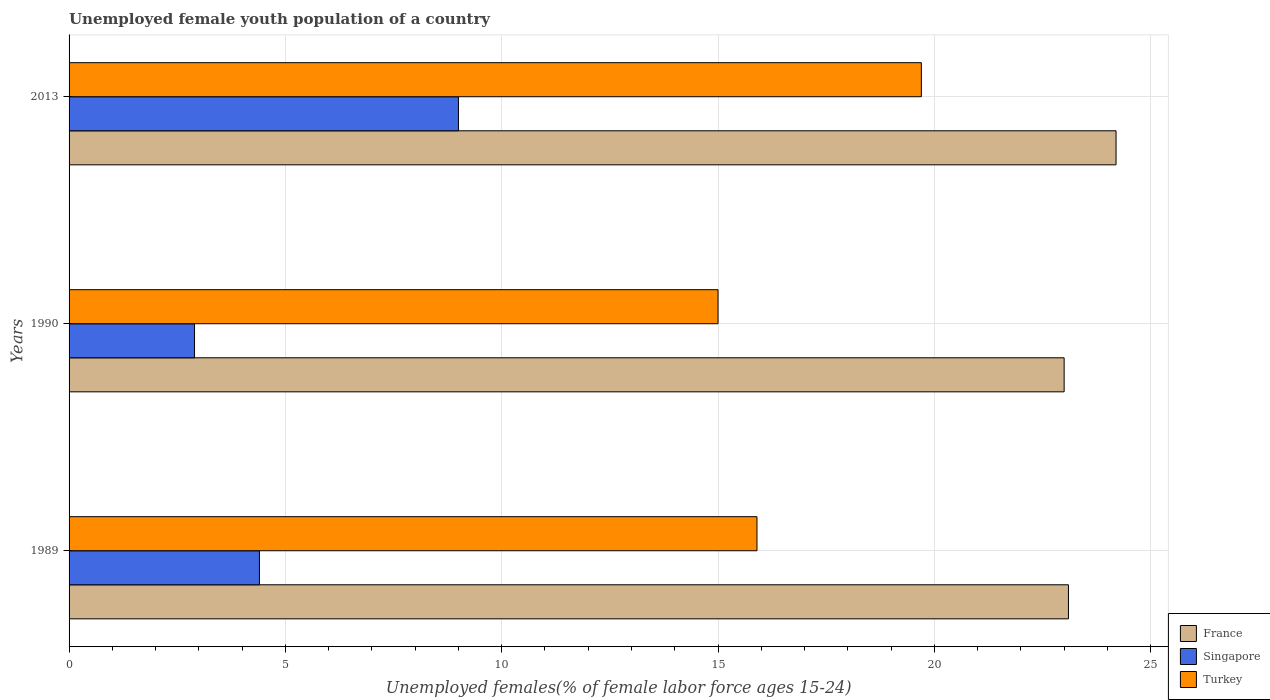How many groups of bars are there?
Offer a very short reply. 3. Are the number of bars per tick equal to the number of legend labels?
Ensure brevity in your answer.  Yes. How many bars are there on the 1st tick from the bottom?
Make the answer very short. 3. What is the label of the 3rd group of bars from the top?
Offer a terse response. 1989. Across all years, what is the maximum percentage of unemployed female youth population in Turkey?
Offer a terse response. 19.7. Across all years, what is the minimum percentage of unemployed female youth population in France?
Give a very brief answer. 23. What is the total percentage of unemployed female youth population in Turkey in the graph?
Make the answer very short. 50.6. What is the difference between the percentage of unemployed female youth population in Turkey in 1989 and that in 2013?
Keep it short and to the point. -3.8. What is the difference between the percentage of unemployed female youth population in Turkey in 1989 and the percentage of unemployed female youth population in Singapore in 2013?
Give a very brief answer. 6.9. What is the average percentage of unemployed female youth population in France per year?
Make the answer very short. 23.43. In the year 1989, what is the difference between the percentage of unemployed female youth population in Turkey and percentage of unemployed female youth population in France?
Offer a very short reply. -7.2. In how many years, is the percentage of unemployed female youth population in Turkey greater than 4 %?
Provide a succinct answer. 3. What is the ratio of the percentage of unemployed female youth population in Singapore in 1989 to that in 2013?
Provide a succinct answer. 0.49. Is the percentage of unemployed female youth population in France in 1989 less than that in 2013?
Your answer should be very brief. Yes. What is the difference between the highest and the second highest percentage of unemployed female youth population in Turkey?
Offer a very short reply. 3.8. What is the difference between the highest and the lowest percentage of unemployed female youth population in France?
Your response must be concise. 1.2. What does the 2nd bar from the top in 1990 represents?
Offer a very short reply. Singapore. What does the 2nd bar from the bottom in 2013 represents?
Provide a short and direct response. Singapore. Is it the case that in every year, the sum of the percentage of unemployed female youth population in Turkey and percentage of unemployed female youth population in Singapore is greater than the percentage of unemployed female youth population in France?
Provide a short and direct response. No. How many bars are there?
Your answer should be very brief. 9. Are all the bars in the graph horizontal?
Your response must be concise. Yes. How many years are there in the graph?
Provide a short and direct response. 3. Are the values on the major ticks of X-axis written in scientific E-notation?
Provide a succinct answer. No. Does the graph contain any zero values?
Give a very brief answer. No. Where does the legend appear in the graph?
Provide a succinct answer. Bottom right. What is the title of the graph?
Provide a short and direct response. Unemployed female youth population of a country. What is the label or title of the X-axis?
Your answer should be very brief. Unemployed females(% of female labor force ages 15-24). What is the Unemployed females(% of female labor force ages 15-24) in France in 1989?
Keep it short and to the point. 23.1. What is the Unemployed females(% of female labor force ages 15-24) of Singapore in 1989?
Give a very brief answer. 4.4. What is the Unemployed females(% of female labor force ages 15-24) in Turkey in 1989?
Offer a terse response. 15.9. What is the Unemployed females(% of female labor force ages 15-24) of France in 1990?
Ensure brevity in your answer.  23. What is the Unemployed females(% of female labor force ages 15-24) of Singapore in 1990?
Provide a short and direct response. 2.9. What is the Unemployed females(% of female labor force ages 15-24) of Turkey in 1990?
Provide a succinct answer. 15. What is the Unemployed females(% of female labor force ages 15-24) of France in 2013?
Your response must be concise. 24.2. What is the Unemployed females(% of female labor force ages 15-24) of Turkey in 2013?
Your answer should be compact. 19.7. Across all years, what is the maximum Unemployed females(% of female labor force ages 15-24) in France?
Keep it short and to the point. 24.2. Across all years, what is the maximum Unemployed females(% of female labor force ages 15-24) in Turkey?
Give a very brief answer. 19.7. Across all years, what is the minimum Unemployed females(% of female labor force ages 15-24) of Singapore?
Give a very brief answer. 2.9. What is the total Unemployed females(% of female labor force ages 15-24) of France in the graph?
Offer a very short reply. 70.3. What is the total Unemployed females(% of female labor force ages 15-24) of Singapore in the graph?
Offer a very short reply. 16.3. What is the total Unemployed females(% of female labor force ages 15-24) in Turkey in the graph?
Give a very brief answer. 50.6. What is the difference between the Unemployed females(% of female labor force ages 15-24) in Singapore in 1989 and that in 1990?
Offer a very short reply. 1.5. What is the difference between the Unemployed females(% of female labor force ages 15-24) in Turkey in 1989 and that in 1990?
Provide a succinct answer. 0.9. What is the difference between the Unemployed females(% of female labor force ages 15-24) of Singapore in 1989 and that in 2013?
Give a very brief answer. -4.6. What is the difference between the Unemployed females(% of female labor force ages 15-24) of France in 1990 and that in 2013?
Provide a short and direct response. -1.2. What is the difference between the Unemployed females(% of female labor force ages 15-24) of France in 1989 and the Unemployed females(% of female labor force ages 15-24) of Singapore in 1990?
Offer a terse response. 20.2. What is the difference between the Unemployed females(% of female labor force ages 15-24) of France in 1989 and the Unemployed females(% of female labor force ages 15-24) of Turkey in 1990?
Your response must be concise. 8.1. What is the difference between the Unemployed females(% of female labor force ages 15-24) in France in 1989 and the Unemployed females(% of female labor force ages 15-24) in Turkey in 2013?
Make the answer very short. 3.4. What is the difference between the Unemployed females(% of female labor force ages 15-24) of Singapore in 1989 and the Unemployed females(% of female labor force ages 15-24) of Turkey in 2013?
Your answer should be very brief. -15.3. What is the difference between the Unemployed females(% of female labor force ages 15-24) in France in 1990 and the Unemployed females(% of female labor force ages 15-24) in Singapore in 2013?
Your answer should be compact. 14. What is the difference between the Unemployed females(% of female labor force ages 15-24) of Singapore in 1990 and the Unemployed females(% of female labor force ages 15-24) of Turkey in 2013?
Make the answer very short. -16.8. What is the average Unemployed females(% of female labor force ages 15-24) of France per year?
Provide a succinct answer. 23.43. What is the average Unemployed females(% of female labor force ages 15-24) of Singapore per year?
Keep it short and to the point. 5.43. What is the average Unemployed females(% of female labor force ages 15-24) in Turkey per year?
Provide a short and direct response. 16.87. In the year 1990, what is the difference between the Unemployed females(% of female labor force ages 15-24) of France and Unemployed females(% of female labor force ages 15-24) of Singapore?
Your response must be concise. 20.1. In the year 1990, what is the difference between the Unemployed females(% of female labor force ages 15-24) in Singapore and Unemployed females(% of female labor force ages 15-24) in Turkey?
Offer a terse response. -12.1. In the year 2013, what is the difference between the Unemployed females(% of female labor force ages 15-24) of France and Unemployed females(% of female labor force ages 15-24) of Singapore?
Offer a terse response. 15.2. What is the ratio of the Unemployed females(% of female labor force ages 15-24) of France in 1989 to that in 1990?
Your answer should be very brief. 1. What is the ratio of the Unemployed females(% of female labor force ages 15-24) of Singapore in 1989 to that in 1990?
Your answer should be very brief. 1.52. What is the ratio of the Unemployed females(% of female labor force ages 15-24) of Turkey in 1989 to that in 1990?
Provide a short and direct response. 1.06. What is the ratio of the Unemployed females(% of female labor force ages 15-24) in France in 1989 to that in 2013?
Your answer should be compact. 0.95. What is the ratio of the Unemployed females(% of female labor force ages 15-24) of Singapore in 1989 to that in 2013?
Give a very brief answer. 0.49. What is the ratio of the Unemployed females(% of female labor force ages 15-24) of Turkey in 1989 to that in 2013?
Offer a very short reply. 0.81. What is the ratio of the Unemployed females(% of female labor force ages 15-24) in France in 1990 to that in 2013?
Keep it short and to the point. 0.95. What is the ratio of the Unemployed females(% of female labor force ages 15-24) in Singapore in 1990 to that in 2013?
Your answer should be compact. 0.32. What is the ratio of the Unemployed females(% of female labor force ages 15-24) in Turkey in 1990 to that in 2013?
Provide a short and direct response. 0.76. What is the difference between the highest and the second highest Unemployed females(% of female labor force ages 15-24) of Singapore?
Provide a short and direct response. 4.6. What is the difference between the highest and the second highest Unemployed females(% of female labor force ages 15-24) in Turkey?
Your answer should be compact. 3.8. What is the difference between the highest and the lowest Unemployed females(% of female labor force ages 15-24) of France?
Your answer should be very brief. 1.2. What is the difference between the highest and the lowest Unemployed females(% of female labor force ages 15-24) of Singapore?
Make the answer very short. 6.1. What is the difference between the highest and the lowest Unemployed females(% of female labor force ages 15-24) of Turkey?
Offer a terse response. 4.7. 